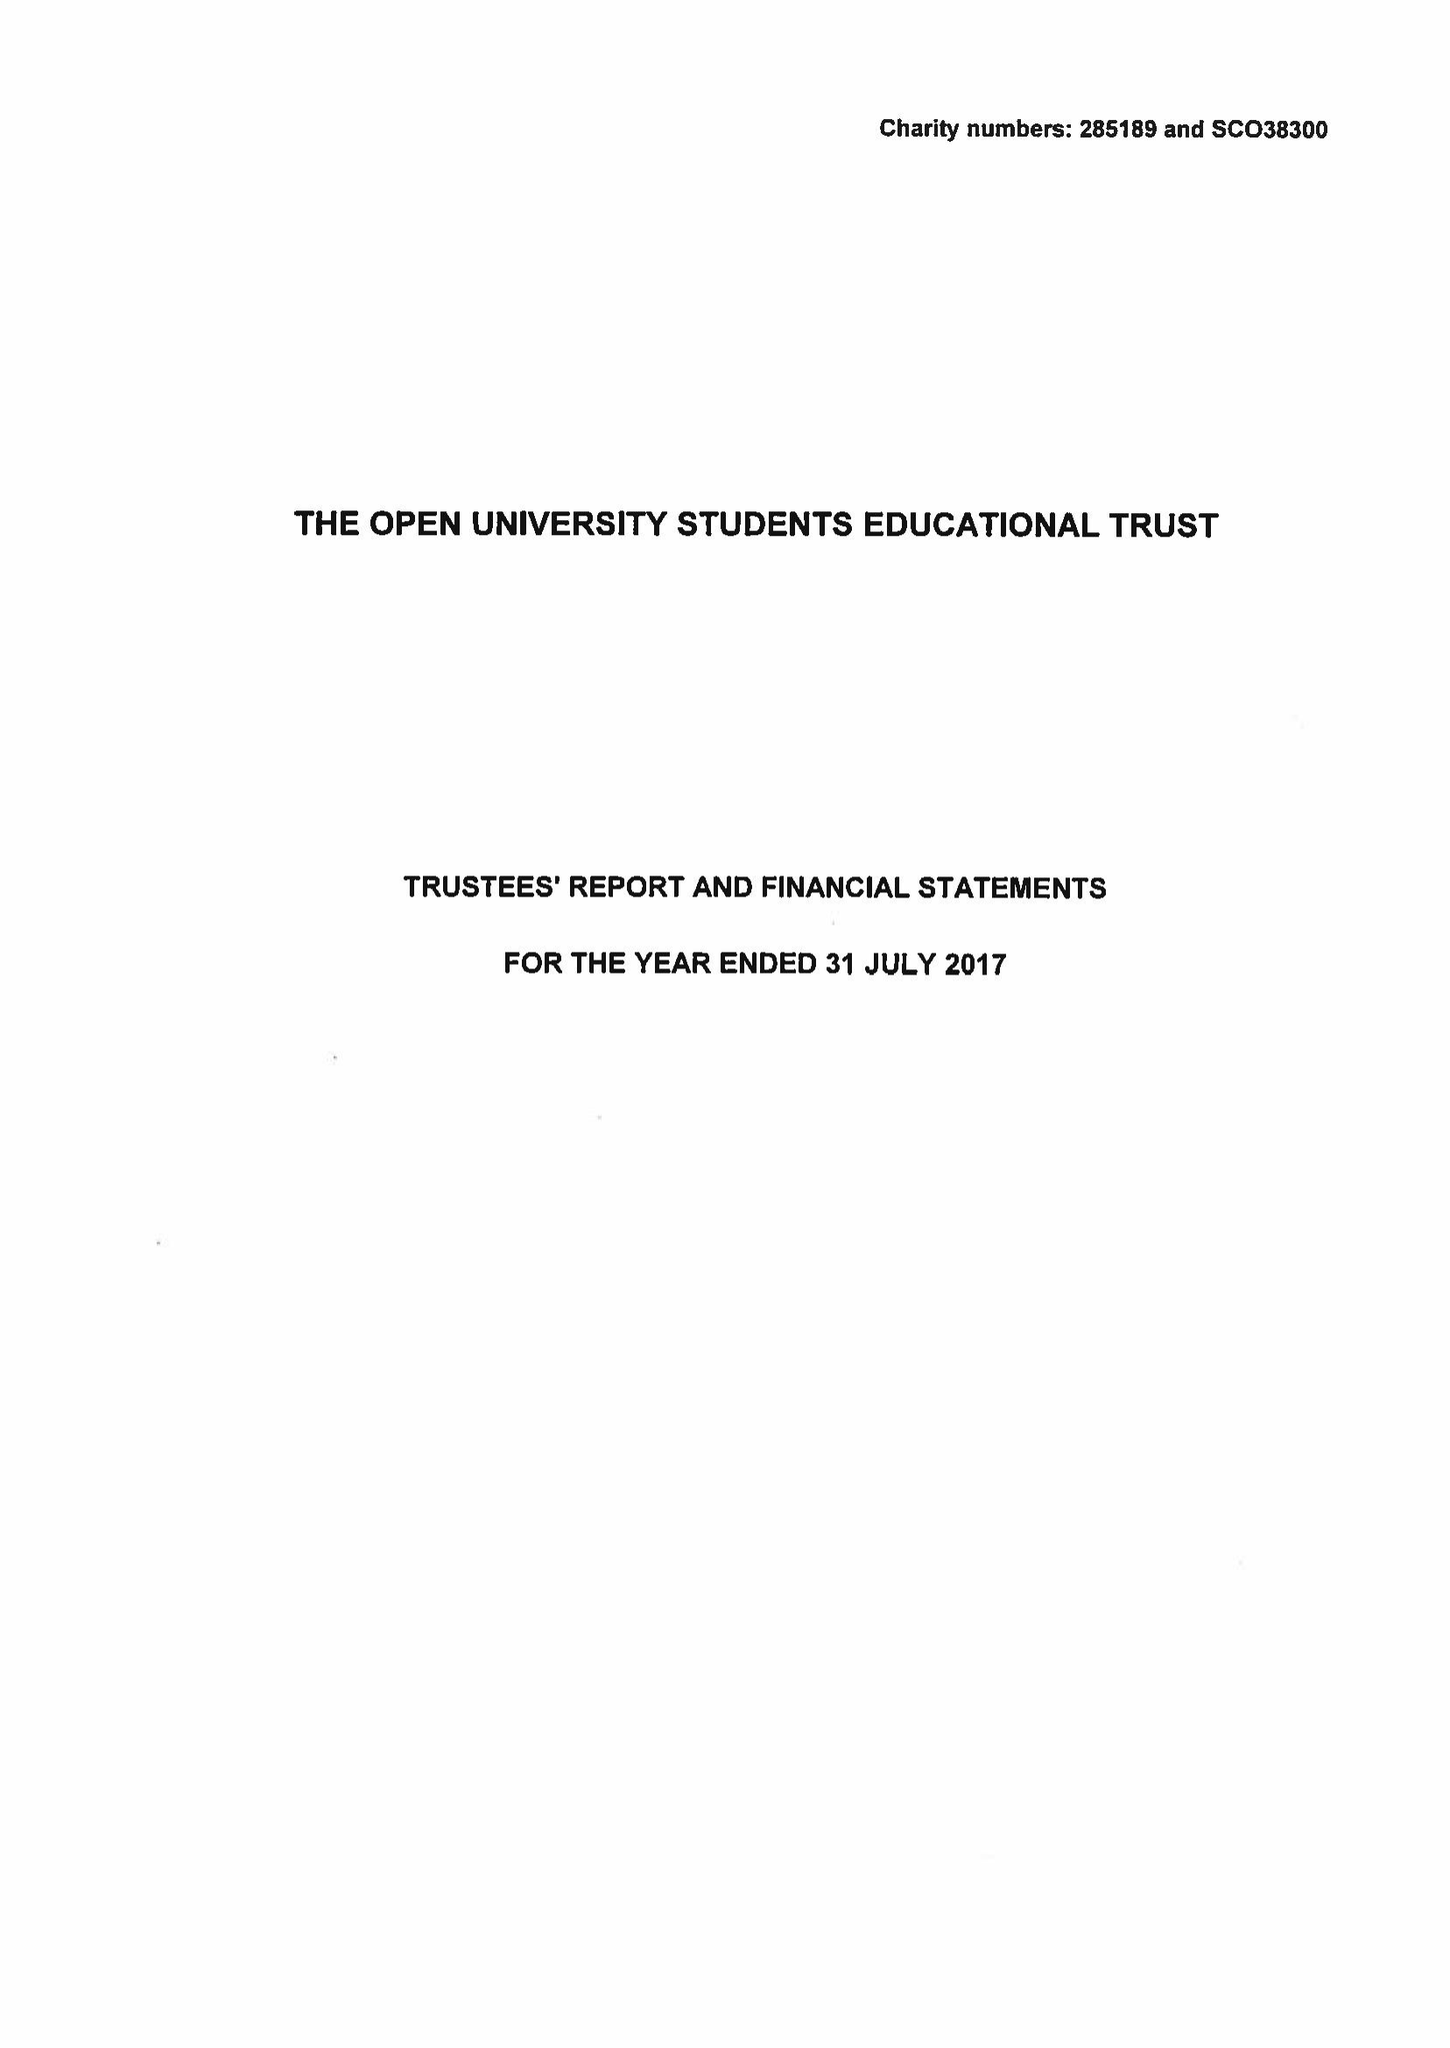What is the value for the spending_annually_in_british_pounds?
Answer the question using a single word or phrase. 272220.00 